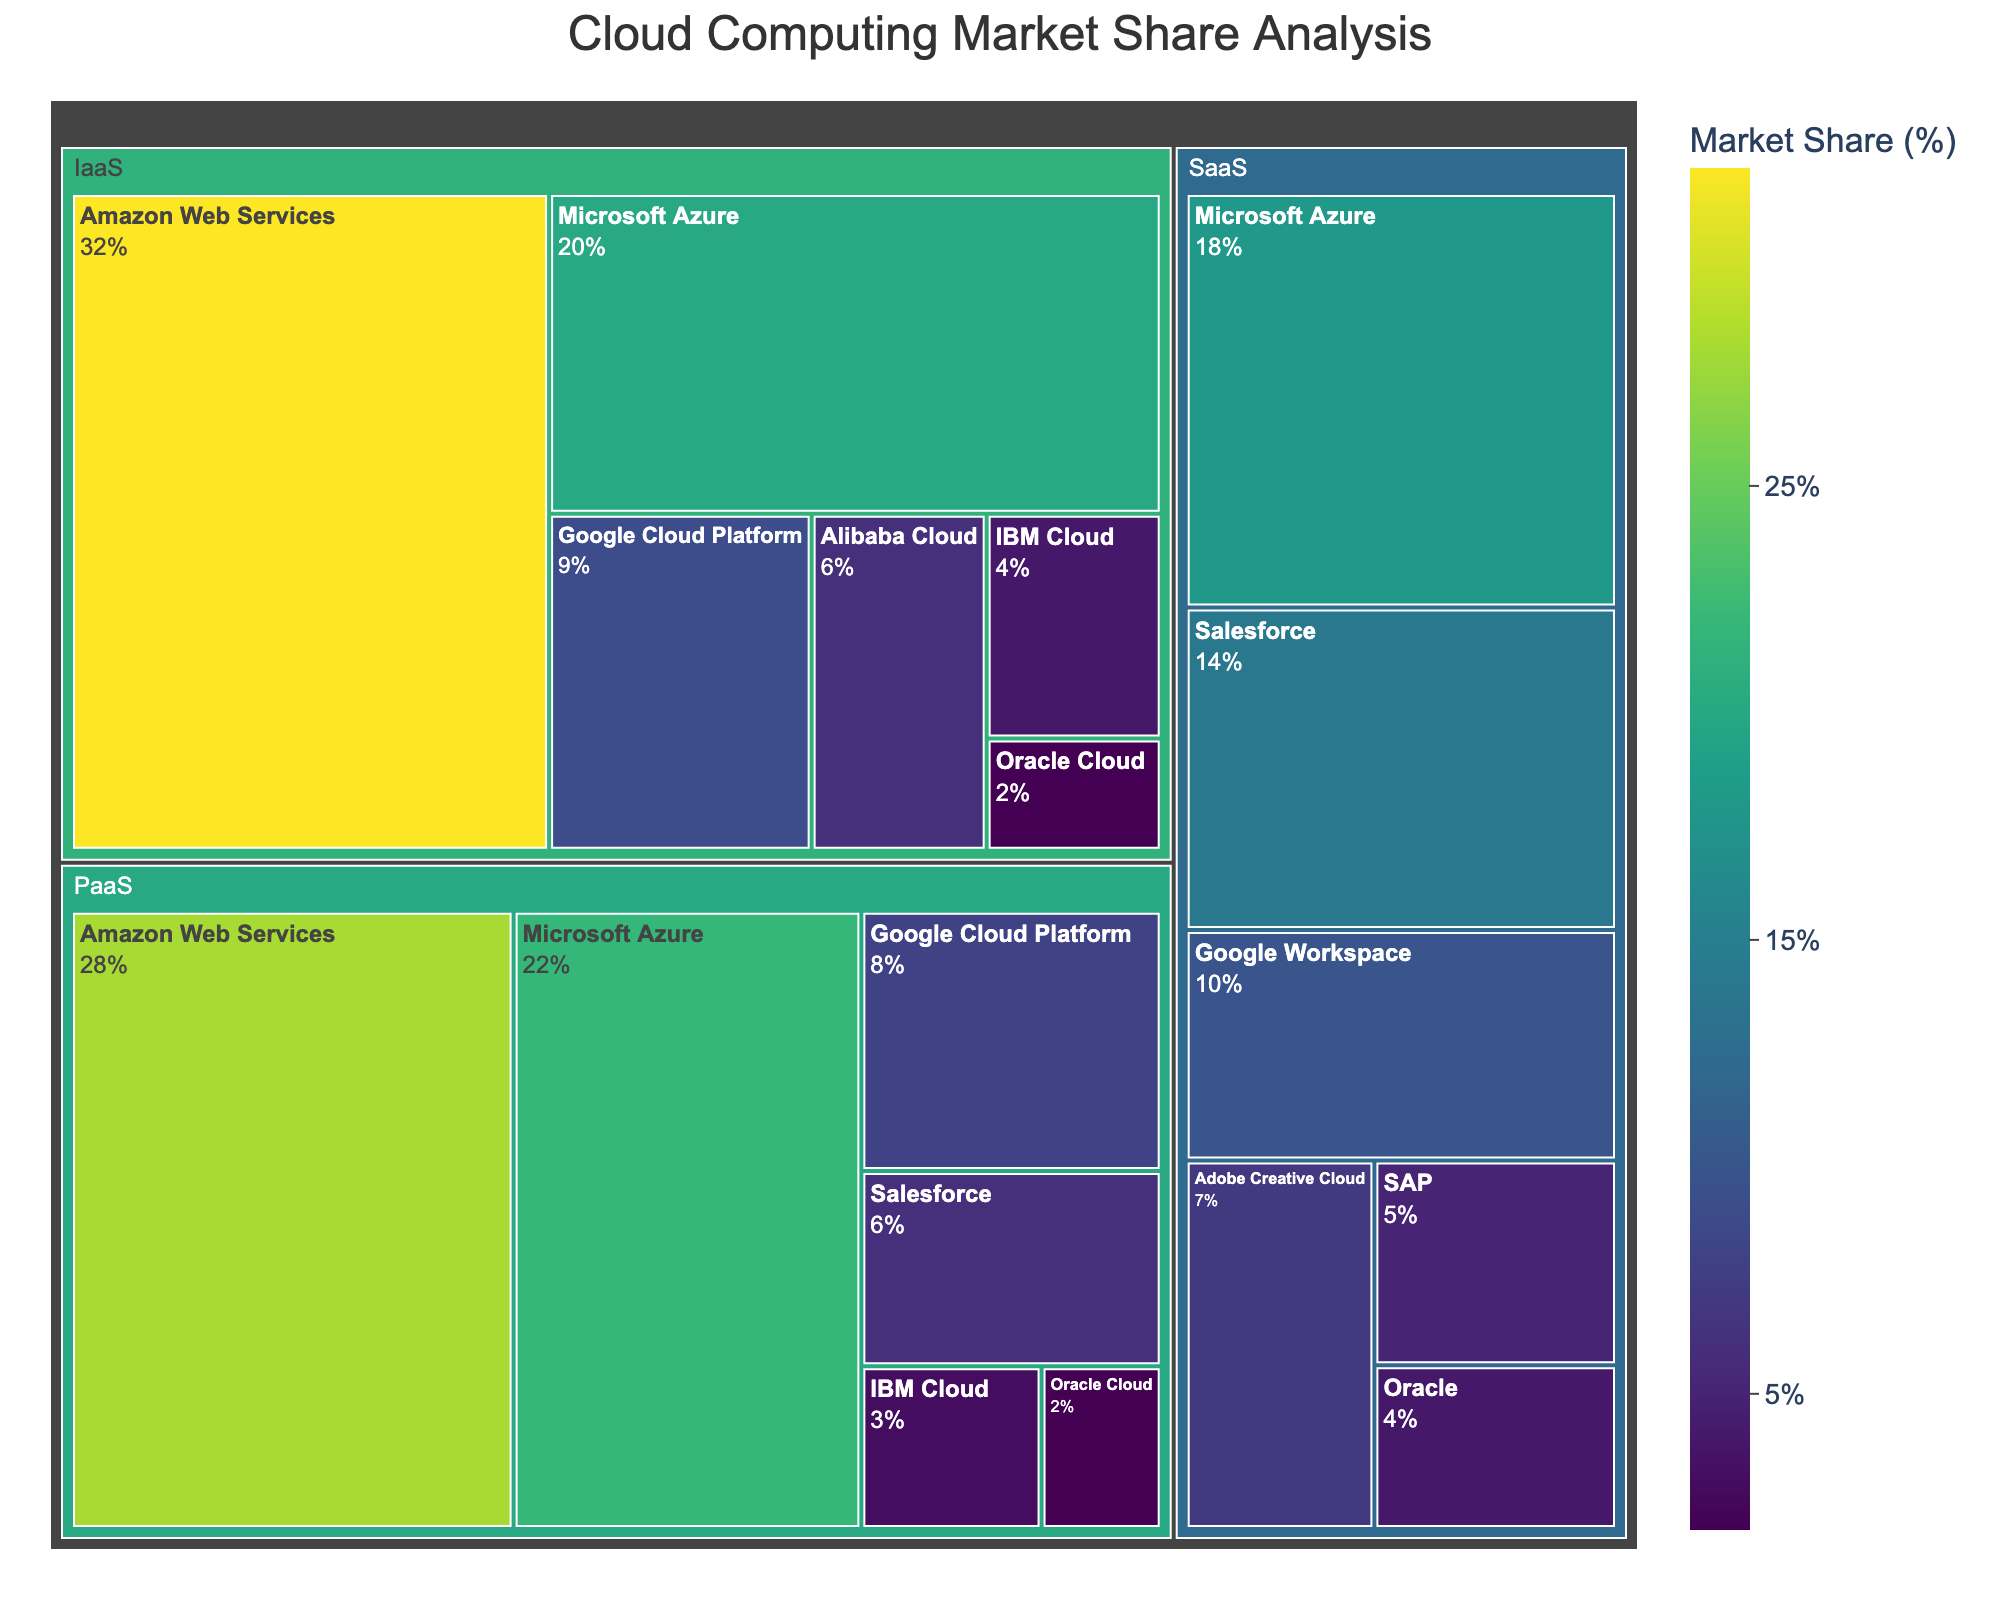What is the title of the treemap? The title is displayed at the top center of the treemap and summarizes the content displayed in the figure.
Answer: Cloud Computing Market Share Analysis Which cloud provider has the highest market share in Infrastructure as a Service (IaaS)? Look at the section for IaaS and identify the cloud provider with the largest area.
Answer: Amazon Web Services Which service type has the highest total market share and which cloud provider contributes most to it? Examine the combined areas of each service type and determine which one is the largest. Within that service type, identify the cloud provider occupying the largest area.
Answer: IaaS, Amazon Web Services How does the market share of Google Cloud Platform in Platform as a Service (PaaS) compare to its market share in Infrastructure as a Service (IaaS)? Check the areas allocated for Google Cloud Platform in both PaaS and IaaS sections and compare their sizes.
Answer: 8% vs 9% Which Service Type and Cloud Provider combination has the lowest market share? Look at the service type with the smallest combined area and then find the smallest segment within that service type.
Answer: IaaS, Oracle Cloud What is the combined market share of Microsoft Azure in all service types? Sum the market shares attributed to Microsoft Azure across IaaS, PaaS, and SaaS.
Answer: 20% + 22% + 18% = 60% Does Amazon Web Services have a higher market share in IaaS or PaaS? Compare the sizes of the areas allocated to Amazon Web Services in IaaS and PaaS.
Answer: IaaS Which service type has the most diverse selection of cloud providers? Look for the service type that contains the most distinct segments representing different cloud providers.
Answer: IaaS What is the market share difference between the largest and smallest cloud providers in PaaS? Identify the market shares of the largest and smallest providers in PaaS and calculate the difference.
Answer: 28% - 2% = 26% What is the average market share for cloud providers within SaaS? Sum the market shares of all cloud providers within SaaS and divide by the number of providers.
Answer: (18 + 14 + 10 + 7 + 5 + 4) / 6 = 58 / 6 ≈ 9.67% 